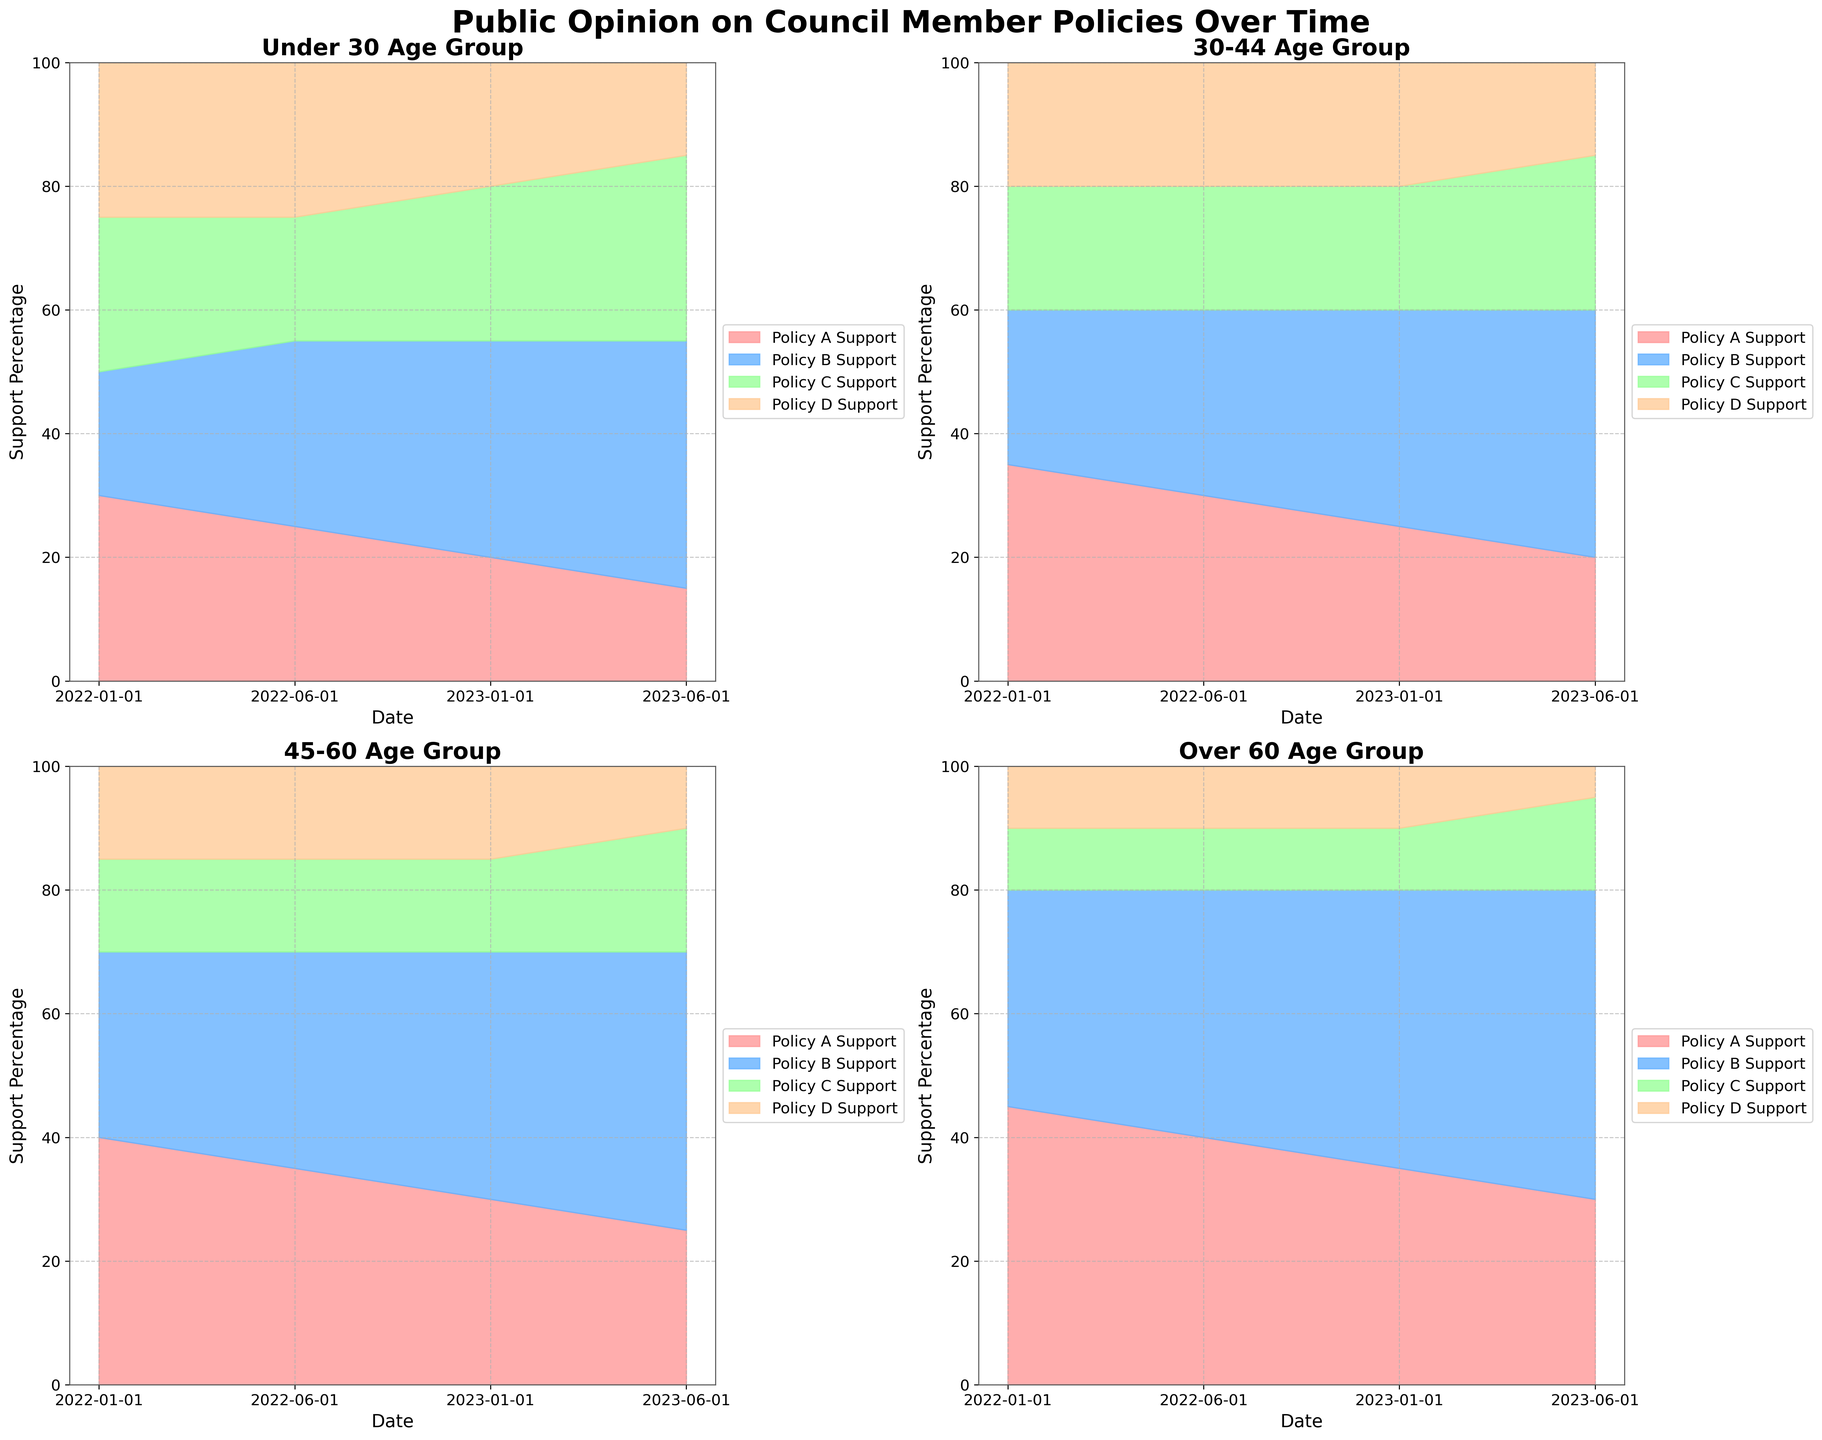What is the title of the figure? The title is provided at the top of the figure. It states the main subject of the figure.
Answer: Public Opinion on Council Member Policies Over Time How many demographic segments are represented in the chart? The figure is divided into four subplots, each representing a different demographic segment.
Answer: Four Which policy has the highest support among the "Under 30" segment in June 2023? To answer this, look at the segment for "Under 30" in June 2023 and identify which color (representing a policy) occupies the largest area within the 100% stacked portion.
Answer: Policy B How does support for Policy C change over time for the "30-44" age group? Examine the positions of the different colors representing Policy C within the "30-44" demographic segment over the different dates shown in the x-axis. Note the ascension or descension of the stacked area's boundary.
Answer: It initially remains stable, increases slightly, then grows more significantly in the last period Which policy appears to have declined in support the most among the "Over 60" segment from January 2022 to June 2023? Look at the "Over 60" segment's area chart and compare the areas of the policies from January 2022 to June 2023.
Answer: Policy D Compare the support for Policy A between the "Under 30" and "Over 60" segments in January 2022. Which group shows higher support? Compare the height of the Policy A area in the "Under 30" and "Over 60" segments in January 2022. The segment with the larger top section of its shaded area shows higher support.
Answer: Over 60 Are there any policies where support is consistently the lowest in all demographic segments throughout the timeline? For each demographic segment, observe the smallest area at each point in time and see if any policy consistently occupies this position.
Answer: Policy D What is the difference in support for Policy B between the "Under 30" and "45-60" segments in January 2023? Look at the height of the portion of the stacked area representing Policy B for both segments in January 2023, then calculate the difference.
Answer: 5% Which demographic segment shows the most significant increase in support for Policy B from January 2022 to June 2023? Examine the area representing Policy B's support in January 2022 and June 2023 across all segments and determine which shows the largest numerical increase.
Answer: Over 60 